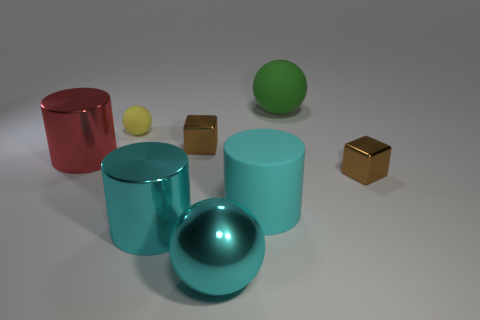There is a green rubber object; is it the same shape as the tiny brown object on the right side of the cyan matte object?
Keep it short and to the point. No. There is a brown metal thing to the left of the large matte thing behind the yellow thing; are there any cyan shiny cylinders that are on the right side of it?
Ensure brevity in your answer.  No. What size is the cyan metal cylinder?
Provide a succinct answer. Large. How many other things are the same color as the large rubber cylinder?
Your answer should be very brief. 2. There is a tiny thing in front of the red metallic thing; is it the same shape as the red shiny object?
Give a very brief answer. No. What is the color of the other tiny matte thing that is the same shape as the green rubber object?
Your response must be concise. Yellow. Is there anything else that is the same material as the green sphere?
Give a very brief answer. Yes. There is another rubber object that is the same shape as the green rubber object; what is its size?
Your response must be concise. Small. What is the material of the object that is behind the matte cylinder and in front of the large red object?
Your response must be concise. Metal. There is a object that is to the right of the green ball; does it have the same color as the metallic sphere?
Give a very brief answer. No. 